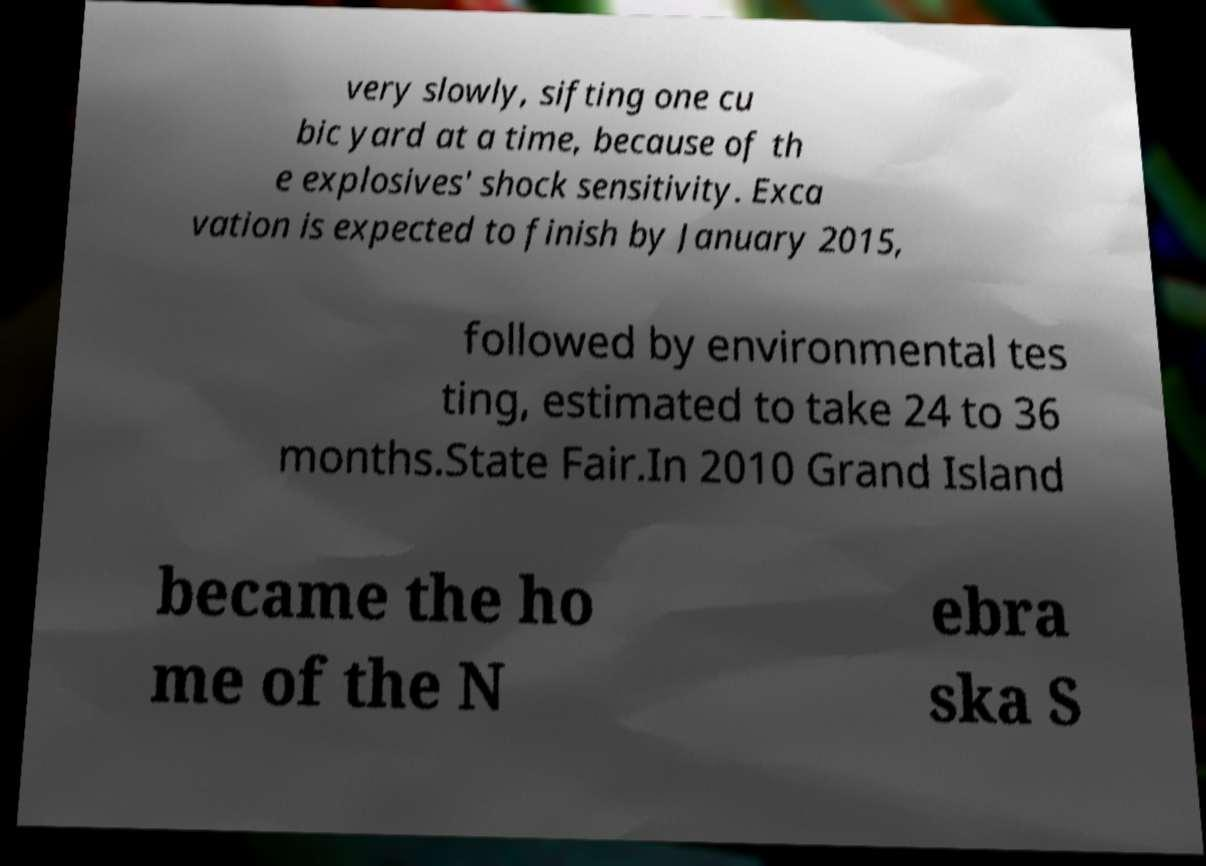Please identify and transcribe the text found in this image. very slowly, sifting one cu bic yard at a time, because of th e explosives' shock sensitivity. Exca vation is expected to finish by January 2015, followed by environmental tes ting, estimated to take 24 to 36 months.State Fair.In 2010 Grand Island became the ho me of the N ebra ska S 